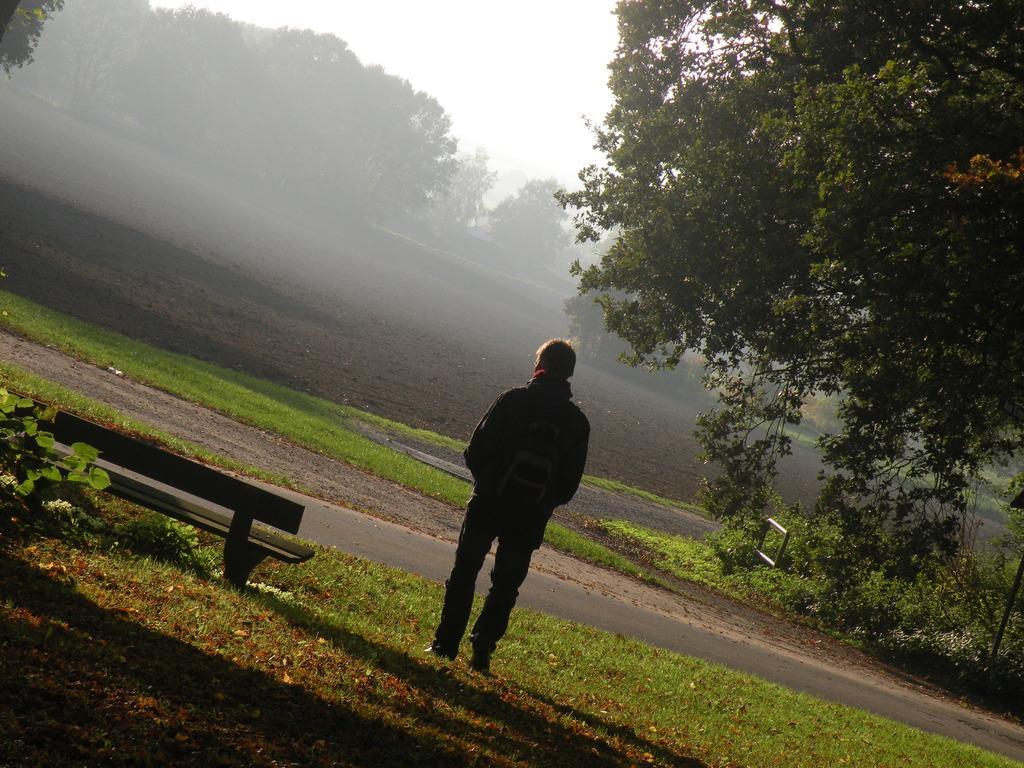How would you summarize this image in a sentence or two? In the center of the image a man is standing. In the background of the image we can see some trees, grass, mud are there. At the top of the image sky is there. On the left side of the image a bench is there. At the bottom of the image we can see some dry leaves, ground are present. 